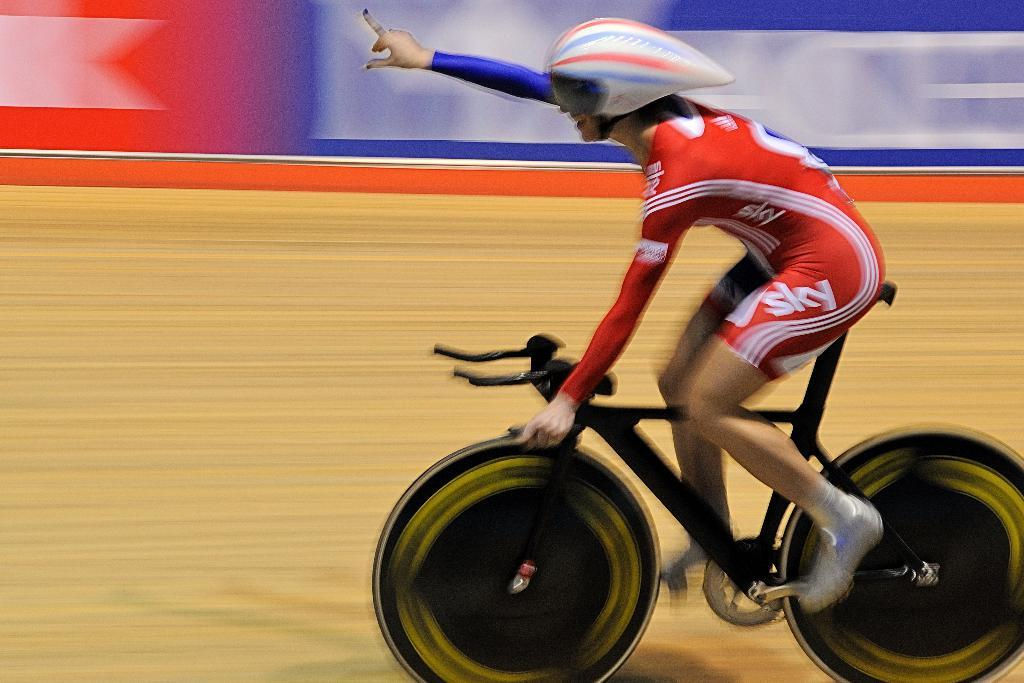<image>
Summarize the visual content of the image. A bicycle racer wearing sky uniform does his no 1 finger gesture as he races. 